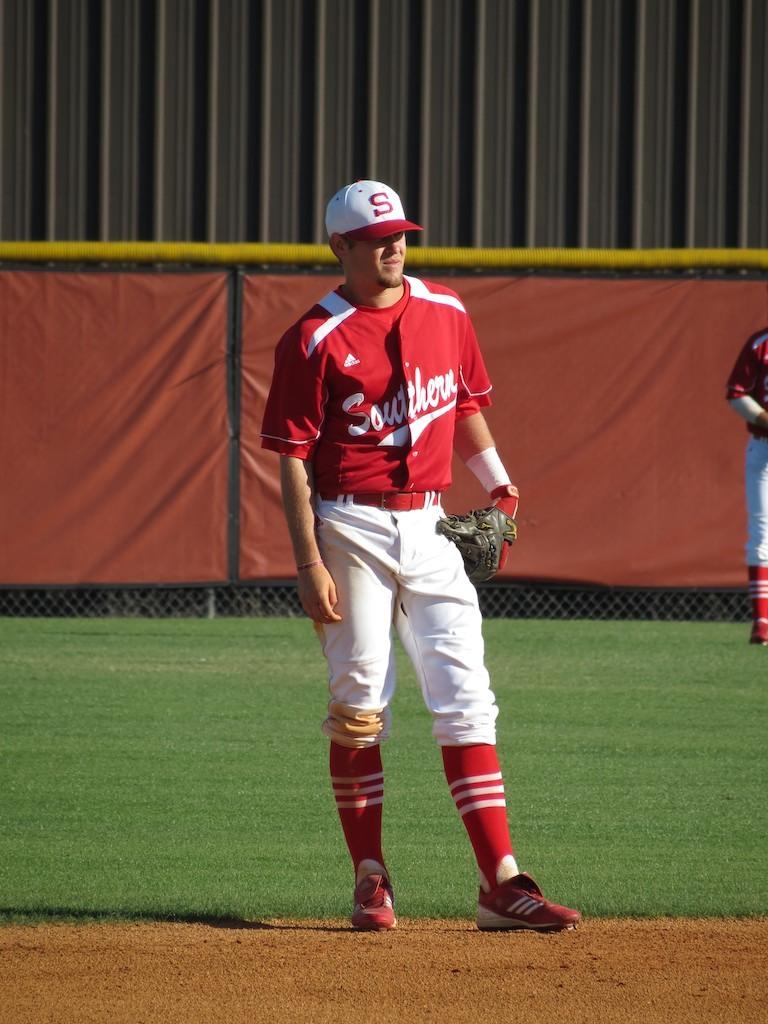Is he on the southern team?
Your answer should be compact. Yes. 